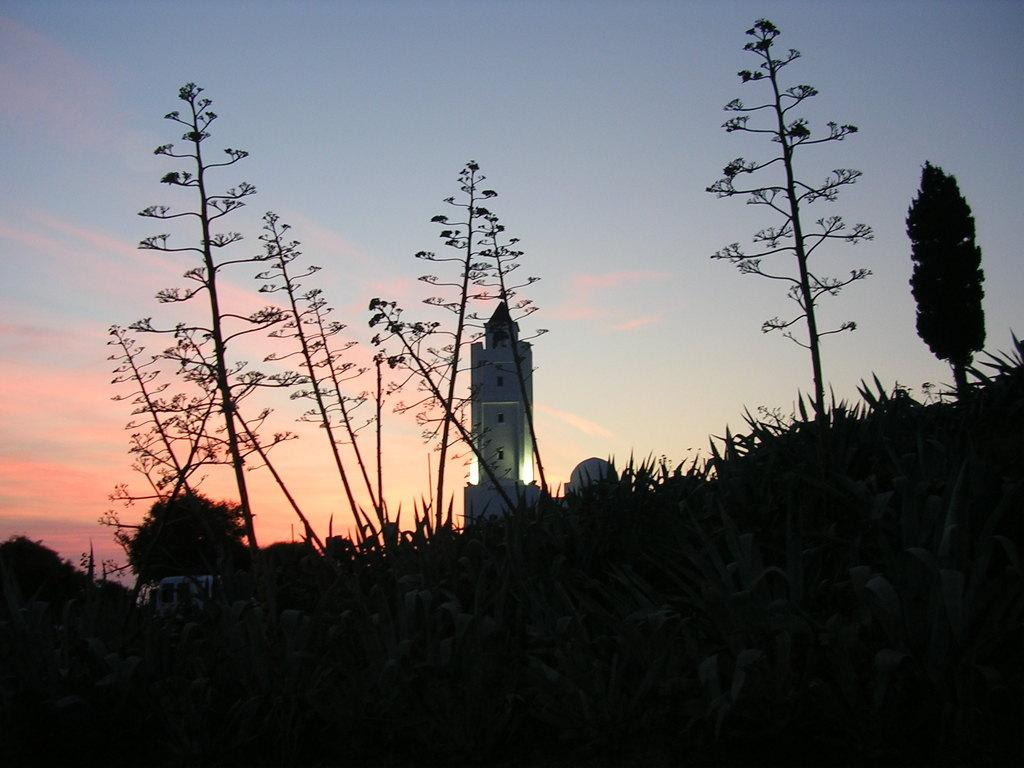What type of vegetation can be seen in the image? There is grass and trees in the image. What type of structure is present in the image? There is a building in the image. What can be seen in the background of the image? The sky is visible in the background of the image. How many heads of lettuce are visible in the image? There is no lettuce present in the image. Is there a crook in the image? There is no crook present in the image. 